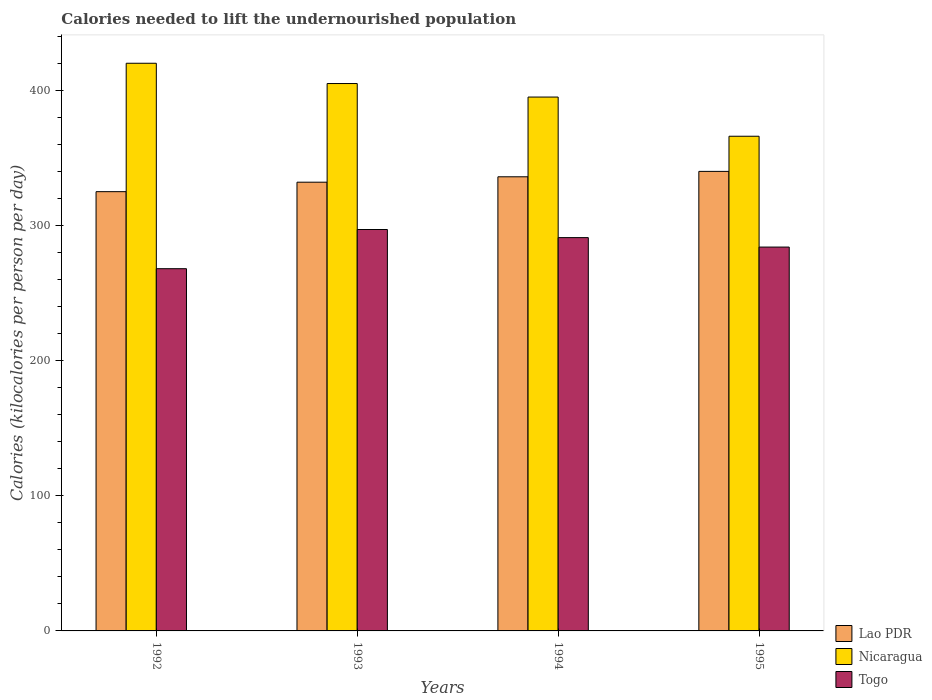How many different coloured bars are there?
Give a very brief answer. 3. Are the number of bars per tick equal to the number of legend labels?
Make the answer very short. Yes. Are the number of bars on each tick of the X-axis equal?
Offer a very short reply. Yes. In how many cases, is the number of bars for a given year not equal to the number of legend labels?
Make the answer very short. 0. What is the total calories needed to lift the undernourished population in Nicaragua in 1992?
Provide a short and direct response. 420. Across all years, what is the maximum total calories needed to lift the undernourished population in Lao PDR?
Offer a very short reply. 340. Across all years, what is the minimum total calories needed to lift the undernourished population in Lao PDR?
Provide a succinct answer. 325. In which year was the total calories needed to lift the undernourished population in Lao PDR maximum?
Keep it short and to the point. 1995. What is the total total calories needed to lift the undernourished population in Nicaragua in the graph?
Provide a succinct answer. 1586. What is the difference between the total calories needed to lift the undernourished population in Lao PDR in 1992 and that in 1993?
Ensure brevity in your answer.  -7. What is the difference between the total calories needed to lift the undernourished population in Lao PDR in 1993 and the total calories needed to lift the undernourished population in Togo in 1995?
Offer a very short reply. 48. What is the average total calories needed to lift the undernourished population in Lao PDR per year?
Your answer should be very brief. 333.25. In the year 1994, what is the difference between the total calories needed to lift the undernourished population in Lao PDR and total calories needed to lift the undernourished population in Nicaragua?
Offer a terse response. -59. What is the ratio of the total calories needed to lift the undernourished population in Nicaragua in 1992 to that in 1995?
Ensure brevity in your answer.  1.15. What is the difference between the highest and the lowest total calories needed to lift the undernourished population in Togo?
Give a very brief answer. 29. In how many years, is the total calories needed to lift the undernourished population in Togo greater than the average total calories needed to lift the undernourished population in Togo taken over all years?
Offer a very short reply. 2. What does the 3rd bar from the left in 1994 represents?
Give a very brief answer. Togo. What does the 3rd bar from the right in 1992 represents?
Ensure brevity in your answer.  Lao PDR. Are all the bars in the graph horizontal?
Your answer should be very brief. No. Does the graph contain grids?
Give a very brief answer. No. How many legend labels are there?
Offer a very short reply. 3. How are the legend labels stacked?
Keep it short and to the point. Vertical. What is the title of the graph?
Give a very brief answer. Calories needed to lift the undernourished population. What is the label or title of the X-axis?
Your answer should be compact. Years. What is the label or title of the Y-axis?
Keep it short and to the point. Calories (kilocalories per person per day). What is the Calories (kilocalories per person per day) of Lao PDR in 1992?
Offer a terse response. 325. What is the Calories (kilocalories per person per day) in Nicaragua in 1992?
Your answer should be very brief. 420. What is the Calories (kilocalories per person per day) of Togo in 1992?
Provide a short and direct response. 268. What is the Calories (kilocalories per person per day) in Lao PDR in 1993?
Provide a succinct answer. 332. What is the Calories (kilocalories per person per day) in Nicaragua in 1993?
Ensure brevity in your answer.  405. What is the Calories (kilocalories per person per day) of Togo in 1993?
Provide a succinct answer. 297. What is the Calories (kilocalories per person per day) in Lao PDR in 1994?
Offer a terse response. 336. What is the Calories (kilocalories per person per day) of Nicaragua in 1994?
Give a very brief answer. 395. What is the Calories (kilocalories per person per day) in Togo in 1994?
Keep it short and to the point. 291. What is the Calories (kilocalories per person per day) in Lao PDR in 1995?
Your answer should be very brief. 340. What is the Calories (kilocalories per person per day) in Nicaragua in 1995?
Offer a very short reply. 366. What is the Calories (kilocalories per person per day) of Togo in 1995?
Your answer should be compact. 284. Across all years, what is the maximum Calories (kilocalories per person per day) in Lao PDR?
Ensure brevity in your answer.  340. Across all years, what is the maximum Calories (kilocalories per person per day) of Nicaragua?
Your answer should be compact. 420. Across all years, what is the maximum Calories (kilocalories per person per day) of Togo?
Ensure brevity in your answer.  297. Across all years, what is the minimum Calories (kilocalories per person per day) in Lao PDR?
Make the answer very short. 325. Across all years, what is the minimum Calories (kilocalories per person per day) in Nicaragua?
Ensure brevity in your answer.  366. Across all years, what is the minimum Calories (kilocalories per person per day) in Togo?
Give a very brief answer. 268. What is the total Calories (kilocalories per person per day) of Lao PDR in the graph?
Offer a terse response. 1333. What is the total Calories (kilocalories per person per day) in Nicaragua in the graph?
Ensure brevity in your answer.  1586. What is the total Calories (kilocalories per person per day) in Togo in the graph?
Your answer should be compact. 1140. What is the difference between the Calories (kilocalories per person per day) of Lao PDR in 1992 and that in 1993?
Give a very brief answer. -7. What is the difference between the Calories (kilocalories per person per day) in Nicaragua in 1992 and that in 1993?
Keep it short and to the point. 15. What is the difference between the Calories (kilocalories per person per day) in Togo in 1992 and that in 1993?
Offer a very short reply. -29. What is the difference between the Calories (kilocalories per person per day) in Lao PDR in 1992 and that in 1994?
Offer a very short reply. -11. What is the difference between the Calories (kilocalories per person per day) in Nicaragua in 1992 and that in 1995?
Give a very brief answer. 54. What is the difference between the Calories (kilocalories per person per day) of Togo in 1992 and that in 1995?
Your response must be concise. -16. What is the difference between the Calories (kilocalories per person per day) in Lao PDR in 1993 and that in 1994?
Provide a succinct answer. -4. What is the difference between the Calories (kilocalories per person per day) of Togo in 1994 and that in 1995?
Your answer should be very brief. 7. What is the difference between the Calories (kilocalories per person per day) of Lao PDR in 1992 and the Calories (kilocalories per person per day) of Nicaragua in 1993?
Ensure brevity in your answer.  -80. What is the difference between the Calories (kilocalories per person per day) in Lao PDR in 1992 and the Calories (kilocalories per person per day) in Togo in 1993?
Provide a short and direct response. 28. What is the difference between the Calories (kilocalories per person per day) in Nicaragua in 1992 and the Calories (kilocalories per person per day) in Togo in 1993?
Your response must be concise. 123. What is the difference between the Calories (kilocalories per person per day) in Lao PDR in 1992 and the Calories (kilocalories per person per day) in Nicaragua in 1994?
Make the answer very short. -70. What is the difference between the Calories (kilocalories per person per day) of Lao PDR in 1992 and the Calories (kilocalories per person per day) of Togo in 1994?
Offer a terse response. 34. What is the difference between the Calories (kilocalories per person per day) of Nicaragua in 1992 and the Calories (kilocalories per person per day) of Togo in 1994?
Offer a very short reply. 129. What is the difference between the Calories (kilocalories per person per day) of Lao PDR in 1992 and the Calories (kilocalories per person per day) of Nicaragua in 1995?
Give a very brief answer. -41. What is the difference between the Calories (kilocalories per person per day) in Lao PDR in 1992 and the Calories (kilocalories per person per day) in Togo in 1995?
Make the answer very short. 41. What is the difference between the Calories (kilocalories per person per day) of Nicaragua in 1992 and the Calories (kilocalories per person per day) of Togo in 1995?
Your answer should be very brief. 136. What is the difference between the Calories (kilocalories per person per day) of Lao PDR in 1993 and the Calories (kilocalories per person per day) of Nicaragua in 1994?
Provide a succinct answer. -63. What is the difference between the Calories (kilocalories per person per day) in Lao PDR in 1993 and the Calories (kilocalories per person per day) in Togo in 1994?
Provide a succinct answer. 41. What is the difference between the Calories (kilocalories per person per day) of Nicaragua in 1993 and the Calories (kilocalories per person per day) of Togo in 1994?
Keep it short and to the point. 114. What is the difference between the Calories (kilocalories per person per day) in Lao PDR in 1993 and the Calories (kilocalories per person per day) in Nicaragua in 1995?
Give a very brief answer. -34. What is the difference between the Calories (kilocalories per person per day) in Lao PDR in 1993 and the Calories (kilocalories per person per day) in Togo in 1995?
Make the answer very short. 48. What is the difference between the Calories (kilocalories per person per day) of Nicaragua in 1993 and the Calories (kilocalories per person per day) of Togo in 1995?
Provide a succinct answer. 121. What is the difference between the Calories (kilocalories per person per day) in Nicaragua in 1994 and the Calories (kilocalories per person per day) in Togo in 1995?
Provide a short and direct response. 111. What is the average Calories (kilocalories per person per day) in Lao PDR per year?
Your answer should be compact. 333.25. What is the average Calories (kilocalories per person per day) in Nicaragua per year?
Give a very brief answer. 396.5. What is the average Calories (kilocalories per person per day) in Togo per year?
Ensure brevity in your answer.  285. In the year 1992, what is the difference between the Calories (kilocalories per person per day) of Lao PDR and Calories (kilocalories per person per day) of Nicaragua?
Your answer should be compact. -95. In the year 1992, what is the difference between the Calories (kilocalories per person per day) in Lao PDR and Calories (kilocalories per person per day) in Togo?
Your response must be concise. 57. In the year 1992, what is the difference between the Calories (kilocalories per person per day) of Nicaragua and Calories (kilocalories per person per day) of Togo?
Your answer should be very brief. 152. In the year 1993, what is the difference between the Calories (kilocalories per person per day) in Lao PDR and Calories (kilocalories per person per day) in Nicaragua?
Offer a terse response. -73. In the year 1993, what is the difference between the Calories (kilocalories per person per day) of Lao PDR and Calories (kilocalories per person per day) of Togo?
Make the answer very short. 35. In the year 1993, what is the difference between the Calories (kilocalories per person per day) in Nicaragua and Calories (kilocalories per person per day) in Togo?
Your answer should be very brief. 108. In the year 1994, what is the difference between the Calories (kilocalories per person per day) in Lao PDR and Calories (kilocalories per person per day) in Nicaragua?
Offer a terse response. -59. In the year 1994, what is the difference between the Calories (kilocalories per person per day) in Lao PDR and Calories (kilocalories per person per day) in Togo?
Ensure brevity in your answer.  45. In the year 1994, what is the difference between the Calories (kilocalories per person per day) in Nicaragua and Calories (kilocalories per person per day) in Togo?
Make the answer very short. 104. In the year 1995, what is the difference between the Calories (kilocalories per person per day) of Nicaragua and Calories (kilocalories per person per day) of Togo?
Make the answer very short. 82. What is the ratio of the Calories (kilocalories per person per day) in Lao PDR in 1992 to that in 1993?
Offer a terse response. 0.98. What is the ratio of the Calories (kilocalories per person per day) in Nicaragua in 1992 to that in 1993?
Offer a terse response. 1.04. What is the ratio of the Calories (kilocalories per person per day) of Togo in 1992 to that in 1993?
Offer a terse response. 0.9. What is the ratio of the Calories (kilocalories per person per day) in Lao PDR in 1992 to that in 1994?
Offer a very short reply. 0.97. What is the ratio of the Calories (kilocalories per person per day) in Nicaragua in 1992 to that in 1994?
Your answer should be compact. 1.06. What is the ratio of the Calories (kilocalories per person per day) of Togo in 1992 to that in 1994?
Offer a very short reply. 0.92. What is the ratio of the Calories (kilocalories per person per day) of Lao PDR in 1992 to that in 1995?
Ensure brevity in your answer.  0.96. What is the ratio of the Calories (kilocalories per person per day) in Nicaragua in 1992 to that in 1995?
Your answer should be compact. 1.15. What is the ratio of the Calories (kilocalories per person per day) of Togo in 1992 to that in 1995?
Keep it short and to the point. 0.94. What is the ratio of the Calories (kilocalories per person per day) of Lao PDR in 1993 to that in 1994?
Provide a short and direct response. 0.99. What is the ratio of the Calories (kilocalories per person per day) of Nicaragua in 1993 to that in 1994?
Offer a terse response. 1.03. What is the ratio of the Calories (kilocalories per person per day) of Togo in 1993 to that in 1994?
Provide a short and direct response. 1.02. What is the ratio of the Calories (kilocalories per person per day) in Lao PDR in 1993 to that in 1995?
Your response must be concise. 0.98. What is the ratio of the Calories (kilocalories per person per day) in Nicaragua in 1993 to that in 1995?
Keep it short and to the point. 1.11. What is the ratio of the Calories (kilocalories per person per day) in Togo in 1993 to that in 1995?
Your answer should be compact. 1.05. What is the ratio of the Calories (kilocalories per person per day) in Nicaragua in 1994 to that in 1995?
Make the answer very short. 1.08. What is the ratio of the Calories (kilocalories per person per day) of Togo in 1994 to that in 1995?
Make the answer very short. 1.02. What is the difference between the highest and the second highest Calories (kilocalories per person per day) of Nicaragua?
Keep it short and to the point. 15. What is the difference between the highest and the lowest Calories (kilocalories per person per day) of Lao PDR?
Your answer should be very brief. 15. What is the difference between the highest and the lowest Calories (kilocalories per person per day) of Togo?
Your answer should be very brief. 29. 